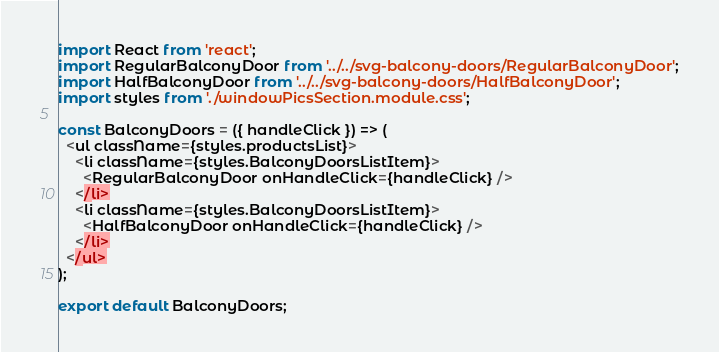<code> <loc_0><loc_0><loc_500><loc_500><_JavaScript_>import React from 'react';
import RegularBalconyDoor from '../../svg-balcony-doors/RegularBalconyDoor';
import HalfBalconyDoor from '../../svg-balcony-doors/HalfBalconyDoor';
import styles from './windowPicsSection.module.css';

const BalconyDoors = ({ handleClick }) => (
  <ul className={styles.productsList}>
    <li className={styles.BalconyDoorsListItem}>
      <RegularBalconyDoor onHandleClick={handleClick} />
    </li>
    <li className={styles.BalconyDoorsListItem}>
      <HalfBalconyDoor onHandleClick={handleClick} />
    </li>
  </ul>
);

export default BalconyDoors;
</code> 